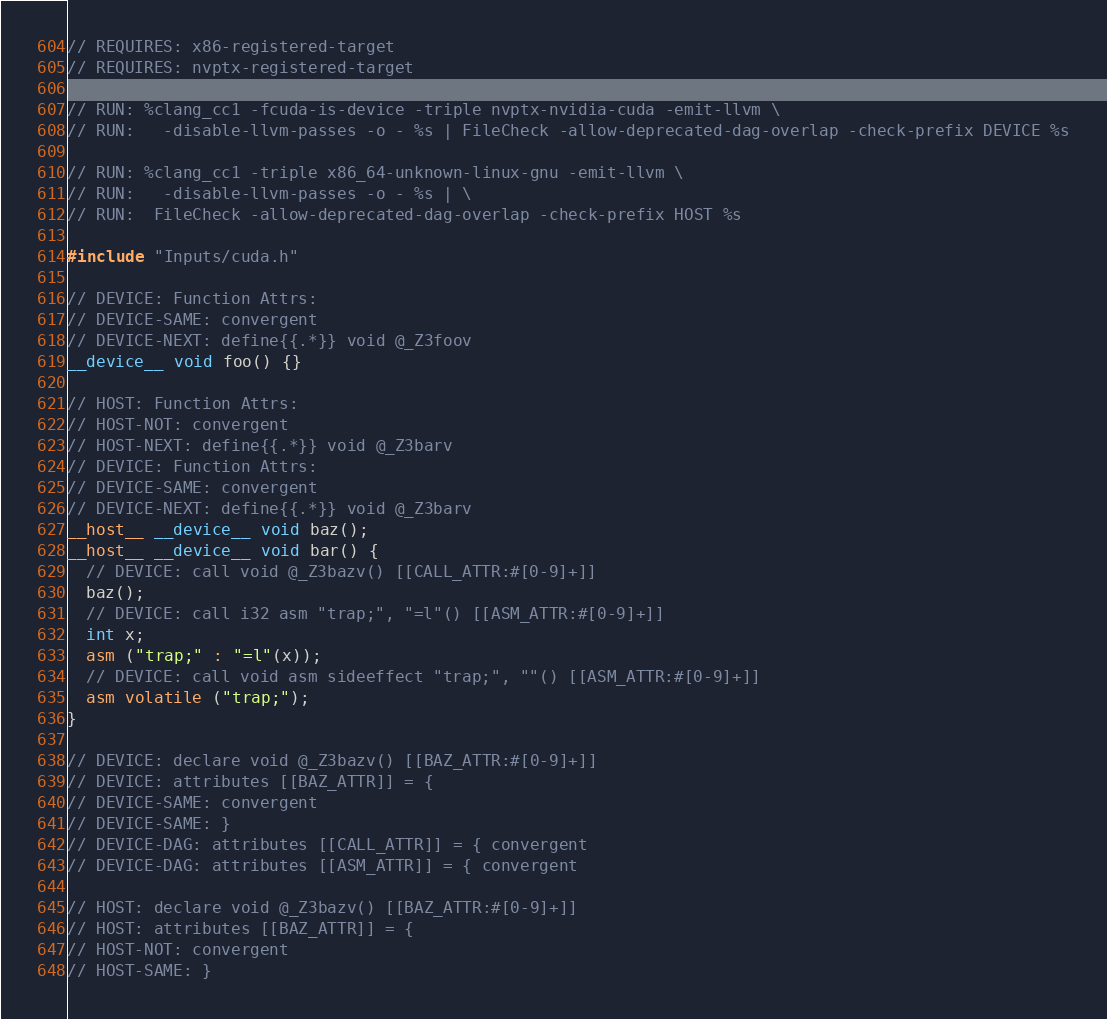<code> <loc_0><loc_0><loc_500><loc_500><_Cuda_>// REQUIRES: x86-registered-target
// REQUIRES: nvptx-registered-target

// RUN: %clang_cc1 -fcuda-is-device -triple nvptx-nvidia-cuda -emit-llvm \
// RUN:   -disable-llvm-passes -o - %s | FileCheck -allow-deprecated-dag-overlap -check-prefix DEVICE %s

// RUN: %clang_cc1 -triple x86_64-unknown-linux-gnu -emit-llvm \
// RUN:   -disable-llvm-passes -o - %s | \
// RUN:  FileCheck -allow-deprecated-dag-overlap -check-prefix HOST %s

#include "Inputs/cuda.h"

// DEVICE: Function Attrs:
// DEVICE-SAME: convergent
// DEVICE-NEXT: define{{.*}} void @_Z3foov
__device__ void foo() {}

// HOST: Function Attrs:
// HOST-NOT: convergent
// HOST-NEXT: define{{.*}} void @_Z3barv
// DEVICE: Function Attrs:
// DEVICE-SAME: convergent
// DEVICE-NEXT: define{{.*}} void @_Z3barv
__host__ __device__ void baz();
__host__ __device__ void bar() {
  // DEVICE: call void @_Z3bazv() [[CALL_ATTR:#[0-9]+]]
  baz();
  // DEVICE: call i32 asm "trap;", "=l"() [[ASM_ATTR:#[0-9]+]]
  int x;
  asm ("trap;" : "=l"(x));
  // DEVICE: call void asm sideeffect "trap;", ""() [[ASM_ATTR:#[0-9]+]]
  asm volatile ("trap;");
}

// DEVICE: declare void @_Z3bazv() [[BAZ_ATTR:#[0-9]+]]
// DEVICE: attributes [[BAZ_ATTR]] = {
// DEVICE-SAME: convergent
// DEVICE-SAME: }
// DEVICE-DAG: attributes [[CALL_ATTR]] = { convergent
// DEVICE-DAG: attributes [[ASM_ATTR]] = { convergent

// HOST: declare void @_Z3bazv() [[BAZ_ATTR:#[0-9]+]]
// HOST: attributes [[BAZ_ATTR]] = {
// HOST-NOT: convergent
// HOST-SAME: }
</code> 